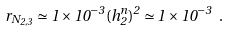Convert formula to latex. <formula><loc_0><loc_0><loc_500><loc_500>r _ { N _ { 2 , 3 } } \simeq 1 \times 1 0 ^ { - 3 } ( h ^ { n } _ { 2 } ) ^ { 2 } \simeq 1 \times 1 0 ^ { - 3 } \ .</formula> 